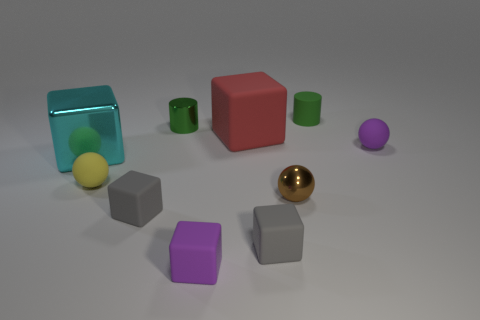Does the red cube have the same material as the tiny purple thing left of the large red rubber thing?
Provide a succinct answer. Yes. Are there any large red matte cylinders?
Keep it short and to the point. No. Are there any rubber blocks to the right of the metallic object behind the rubber object that is to the right of the green matte thing?
Ensure brevity in your answer.  Yes. How many big things are cyan cubes or matte things?
Provide a succinct answer. 2. The matte cube that is the same size as the cyan shiny block is what color?
Offer a terse response. Red. There is a cyan thing; how many big red rubber cubes are to the left of it?
Give a very brief answer. 0. Are there any small green objects made of the same material as the red object?
Ensure brevity in your answer.  Yes. There is a tiny matte object that is the same color as the metal cylinder; what shape is it?
Provide a succinct answer. Cylinder. The tiny metallic thing behind the large matte cube is what color?
Keep it short and to the point. Green. Are there the same number of big red matte cubes in front of the brown sphere and green cylinders on the right side of the big cyan thing?
Offer a terse response. No. 